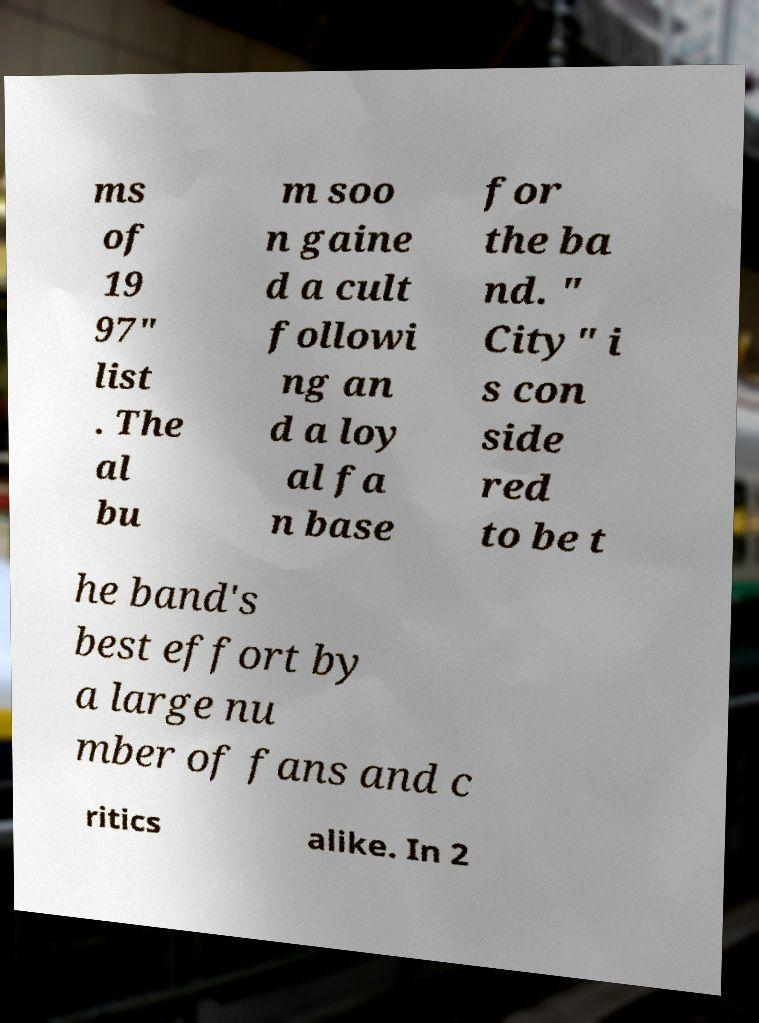There's text embedded in this image that I need extracted. Can you transcribe it verbatim? ms of 19 97" list . The al bu m soo n gaine d a cult followi ng an d a loy al fa n base for the ba nd. " City" i s con side red to be t he band's best effort by a large nu mber of fans and c ritics alike. In 2 